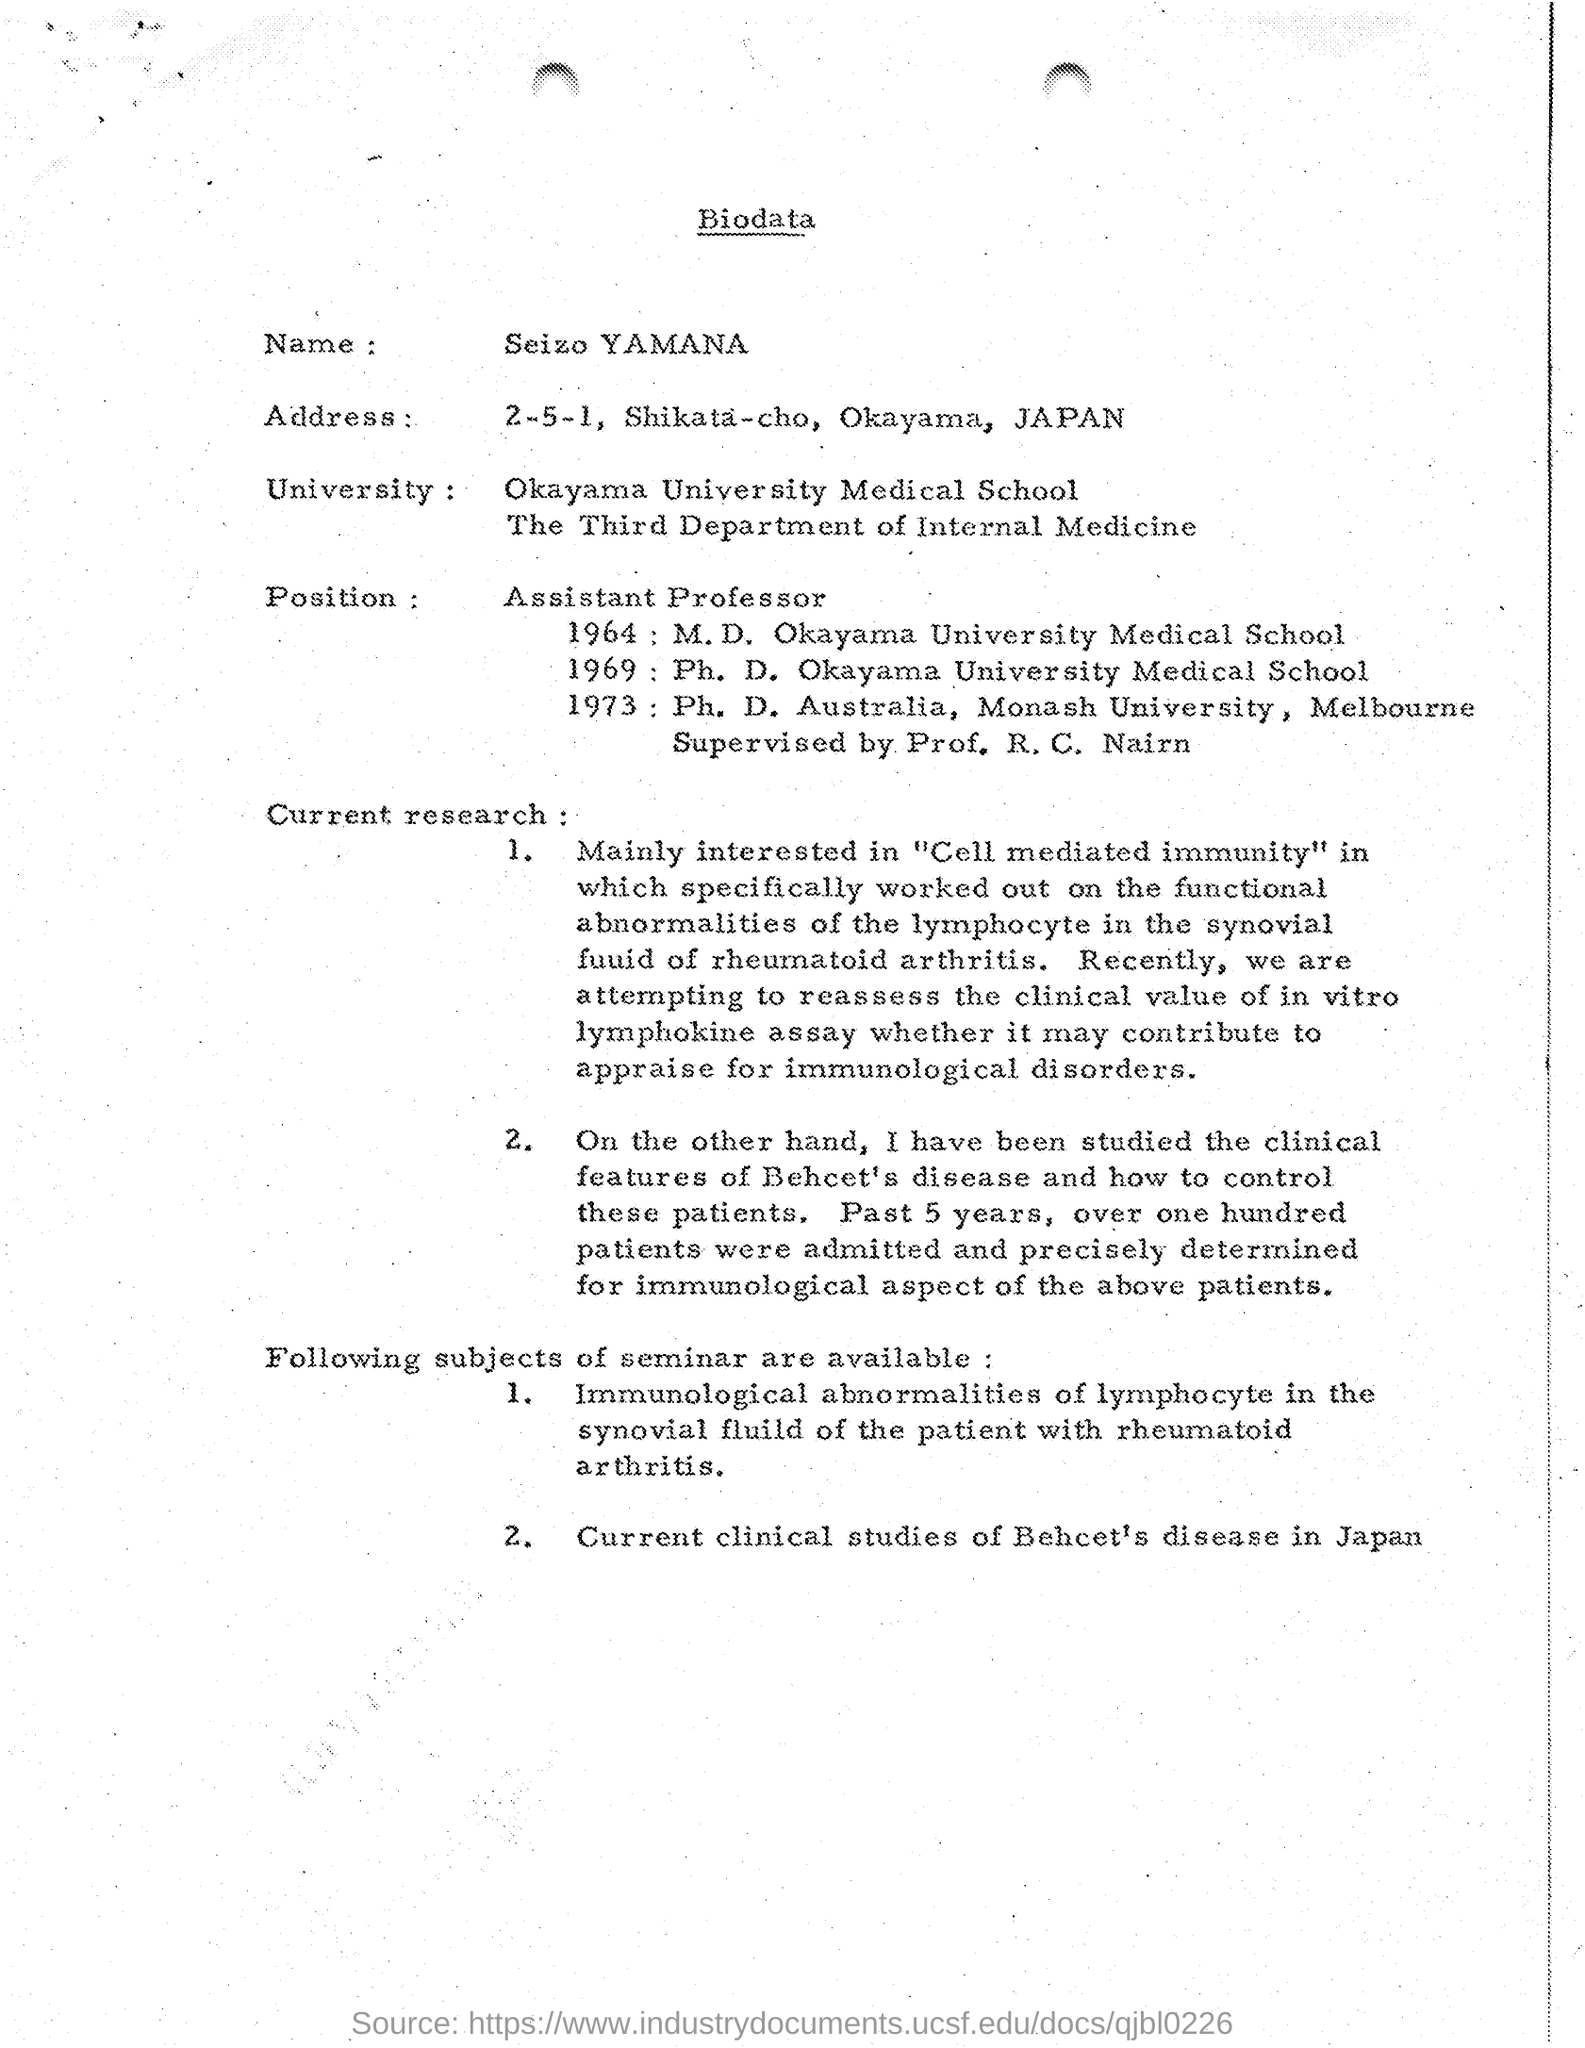What is the name mentioned in the biodata ?
Your answer should be compact. Seizo YAMANA. What is the position mentioned in the given biodata ?
Ensure brevity in your answer.  Assistant Professor. 